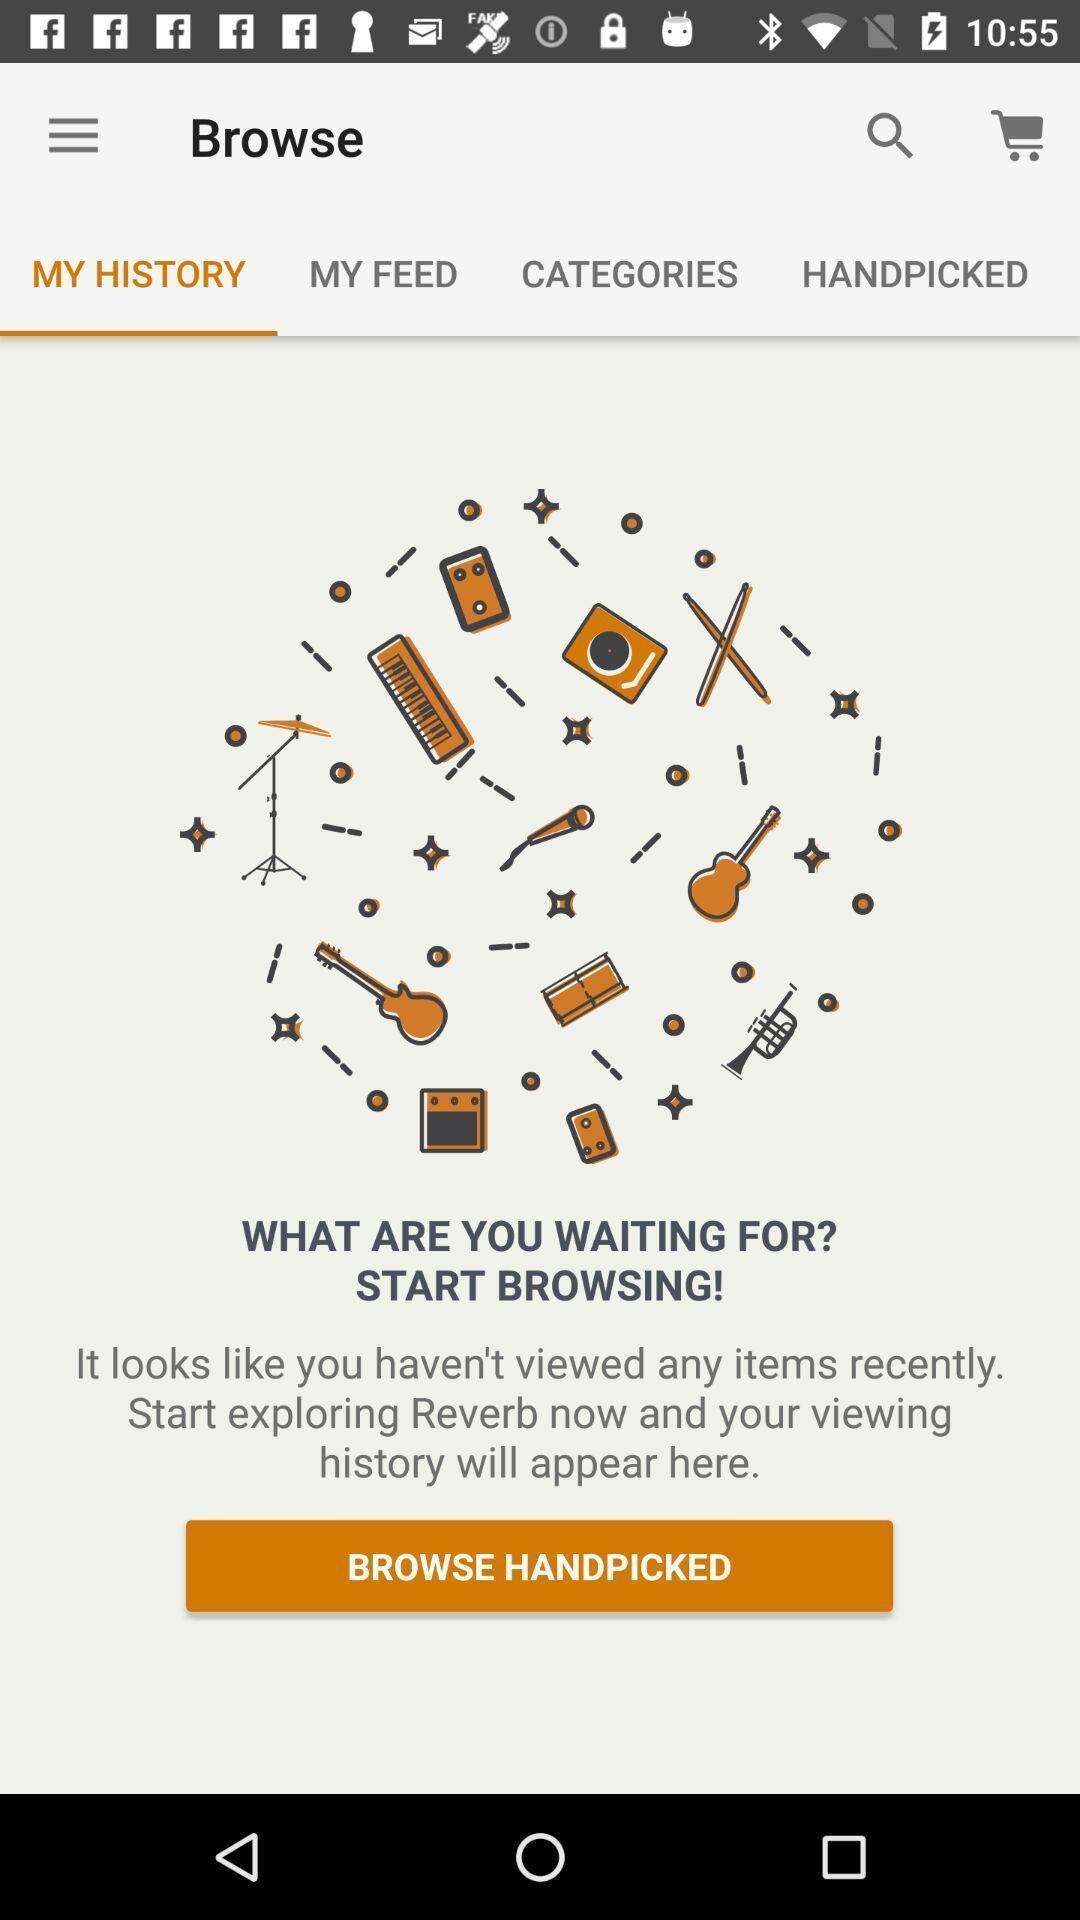Provide a textual representation of this image. Screen displaying the history in a browsing application. 